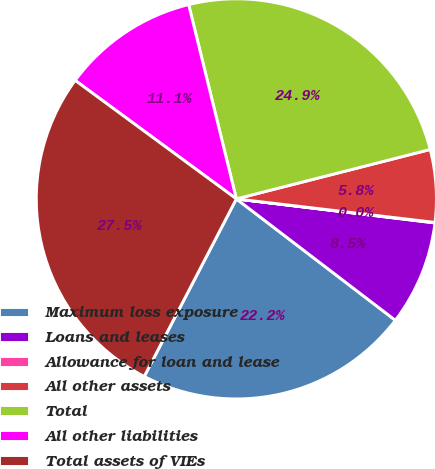Convert chart to OTSL. <chart><loc_0><loc_0><loc_500><loc_500><pie_chart><fcel>Maximum loss exposure<fcel>Loans and leases<fcel>Allowance for loan and lease<fcel>All other assets<fcel>Total<fcel>All other liabilities<fcel>Total assets of VIEs<nl><fcel>22.24%<fcel>8.46%<fcel>0.04%<fcel>5.85%<fcel>24.86%<fcel>11.08%<fcel>27.47%<nl></chart> 